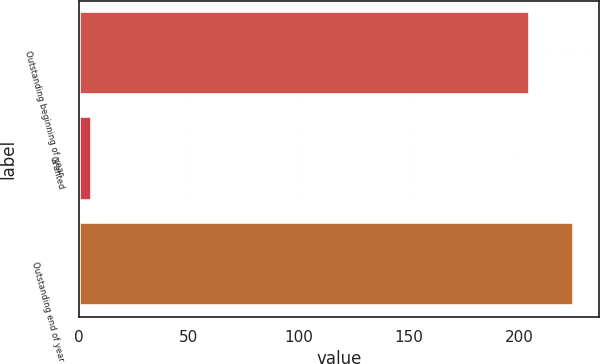<chart> <loc_0><loc_0><loc_500><loc_500><bar_chart><fcel>Outstanding beginning of year<fcel>Granted<fcel>Outstanding end of year<nl><fcel>205<fcel>6<fcel>225.1<nl></chart> 